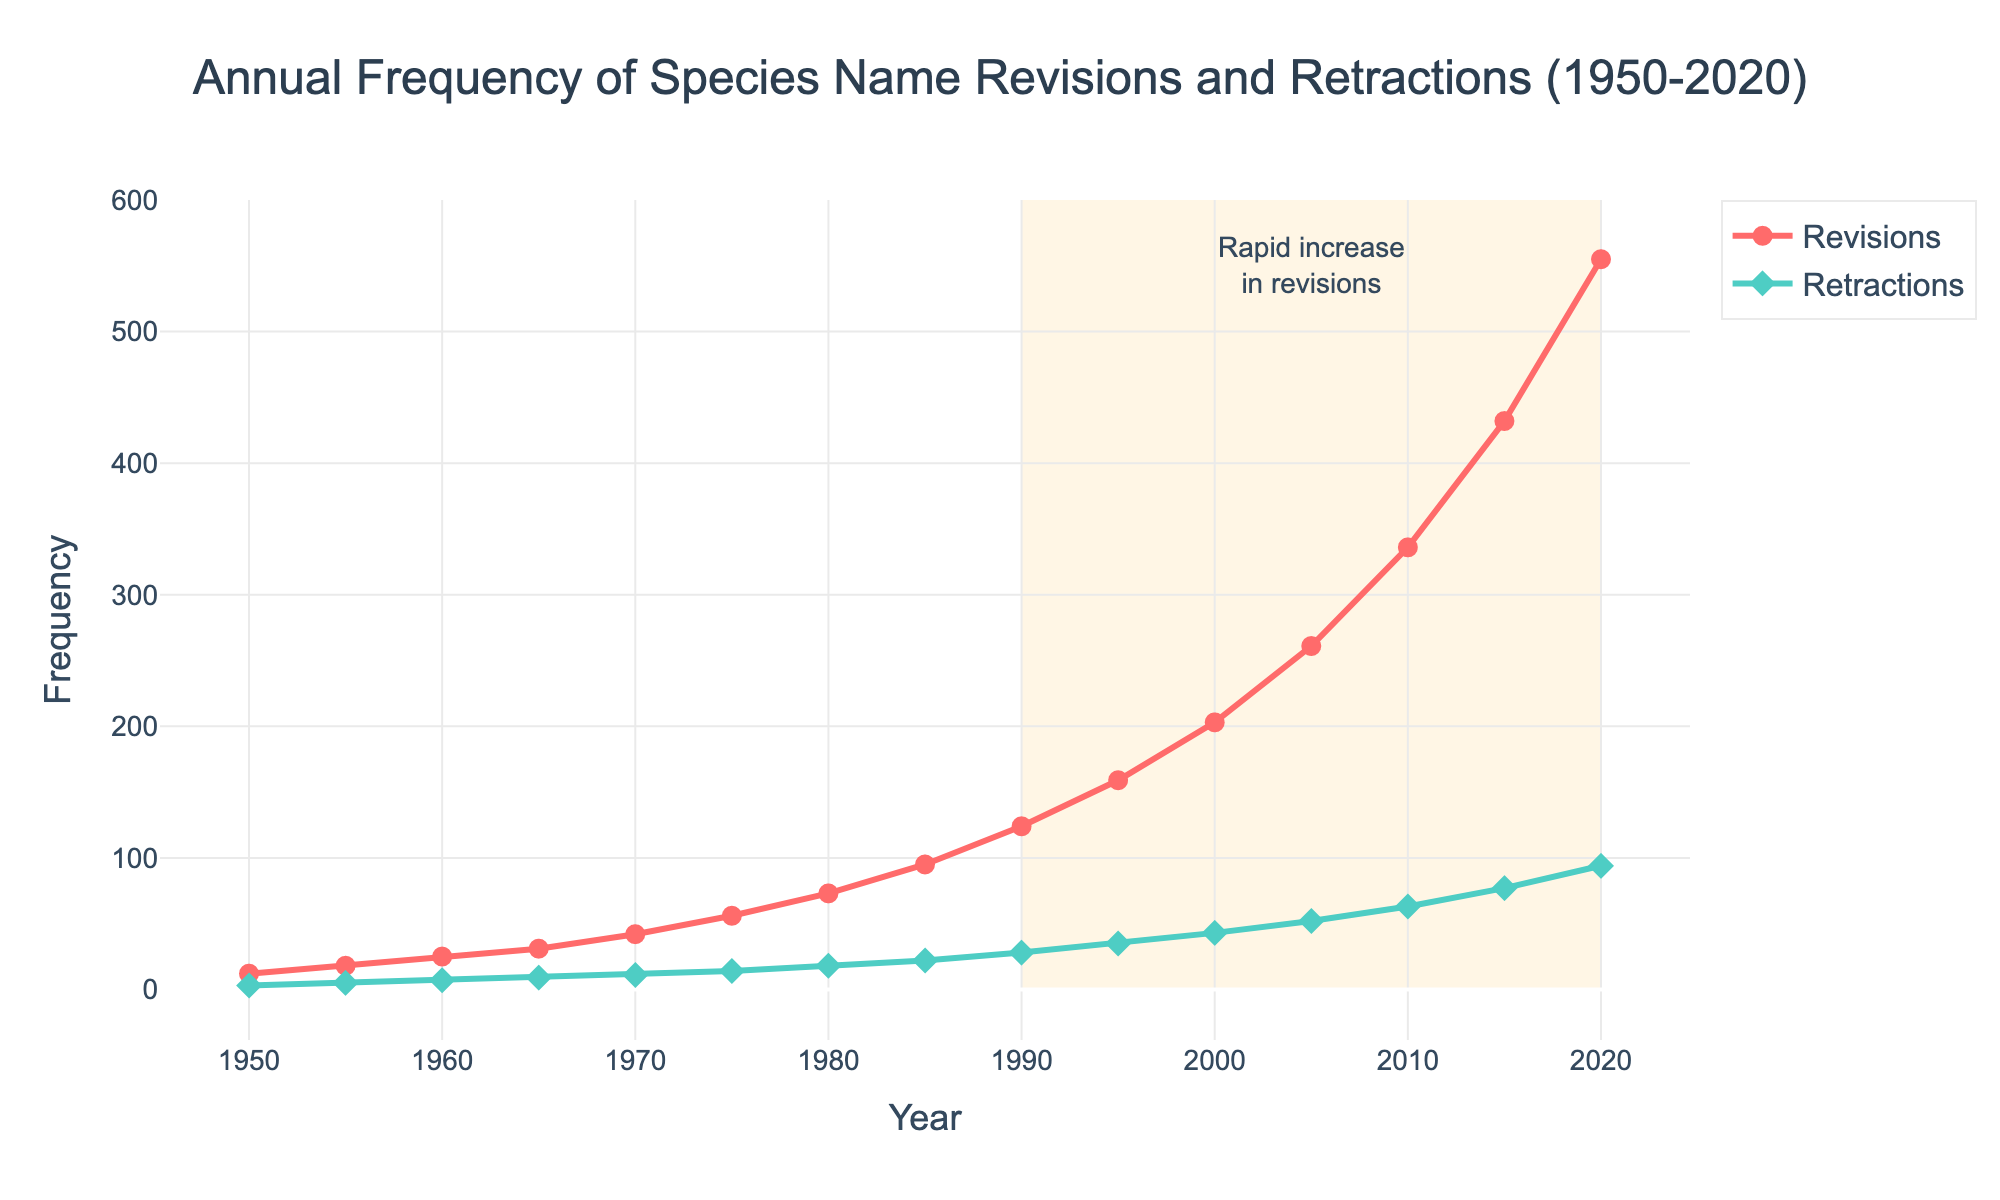What is the number of species name retractions in 1980? To find the number of species name retractions in 1980, locate the year on the x-axis and read the corresponding value on the y-axis for the "Species Name Retractions" line (green line with diamond markers). The value is 18.
Answer: 18 What year had the highest number of species name revisions? Locate the peak of the "Revisions" line (red line with circle markers) on the plot. The highest point on this line is in the year 2020 with a value of 555.
Answer: 2020 Compare the frequency of species name revisions and retractions in 1975. Which was higher and by how much? For 1975, read the values for both series from the plot. Revisions are at 56 and Retractions are at 14. Calculate the difference: 56 - 14 = 42. Revisions were higher by 42.
Answer: Revisions by 42 What is the average frequency of species name revisions from 1955 to 1970 (inclusive)? Identify the values for the years 1955 (18), 1960 (25), 1965 (31), and 1970 (42). Sum these values: 18 + 25 + 31 + 42 = 116. Divide by the number of years: 116 / 4 = 29.
Answer: 29 In which period did retractions start to increase noticeably, and what is the visual cue that indicates this? Observe the "Species Name Retractions" line and identify the period when the slope starts to increase sharply. From 1980 onwards, there is a noticeable upward trend. This is also visually highlighted by the more pronounced rise of the green line starting around this period.
Answer: 1980 onwards Calculate the total number of species name revisions between 1950 and 1990. Add the values from 1950 (12), 1955 (18), 1960 (25), 1965 (31), 1970 (42), 1975 (56), 1980 (73), 1985 (95), and 1990 (124). The sum is 12 + 18 + 25 + 31 + 42 + 56 + 73 + 95 + 124 = 476.
Answer: 476 How does the frequency of species name revisions in 2010 compare to the frequency in 2000? What’s the difference? Revisions in 2010 are at 336 and in 2000 are at 203. Subtract the 2000 value from the 2010 value: 336 - 203 = 133.
Answer: 133 What is the color used to represent the species name revisions line? Identify the color of the line with circle markers representing "Species Name Revisions" on the plot. It is red.
Answer: Red 